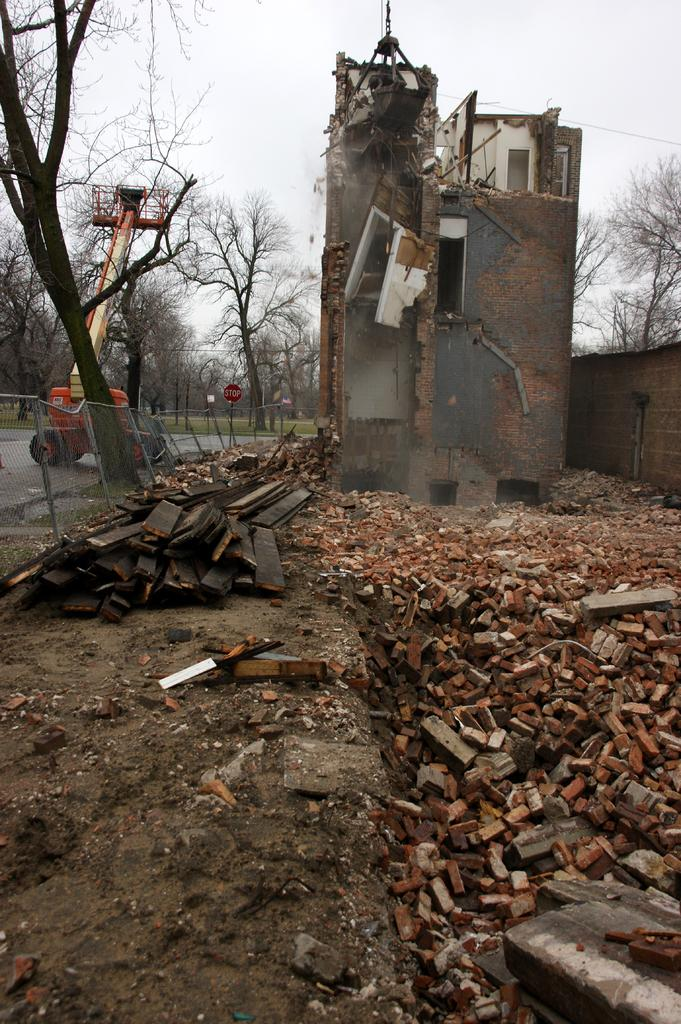What is the main subject of the image? The main subject of the image is a demolished house. What can be seen around the demolished house? There are broken pieces of bricks and walls near the demolished house. What is visible in the background of the image? Trees and the sky are visible in the background of the image. Can you see a toad sitting on a pear near the seashore in the image? No, there is no toad, pear, or seashore present in the image. 